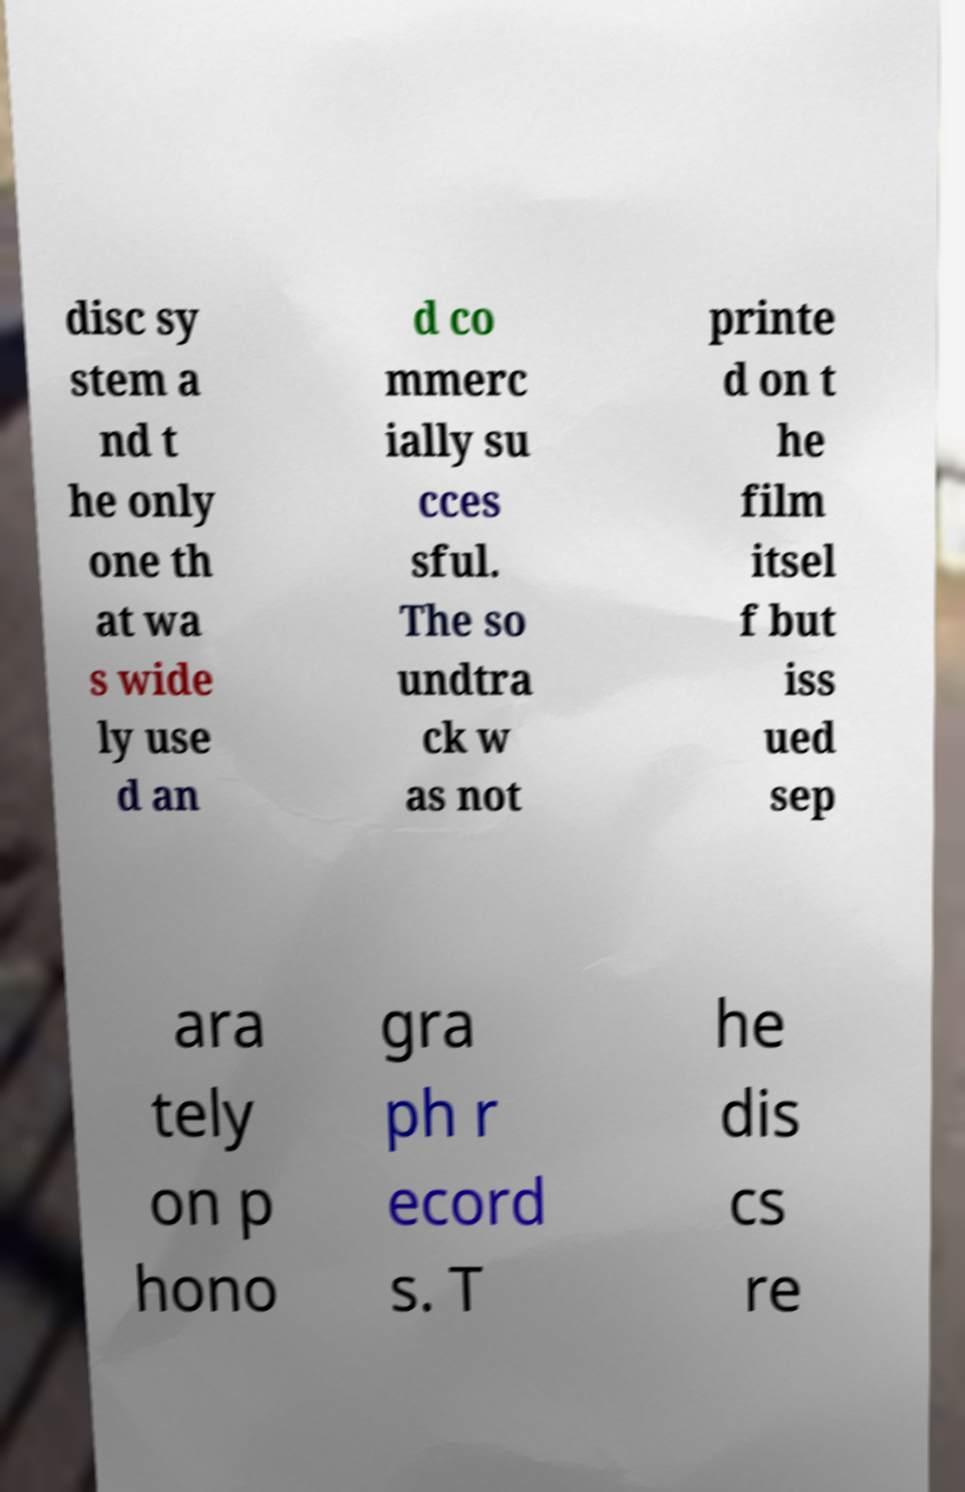Could you assist in decoding the text presented in this image and type it out clearly? disc sy stem a nd t he only one th at wa s wide ly use d an d co mmerc ially su cces sful. The so undtra ck w as not printe d on t he film itsel f but iss ued sep ara tely on p hono gra ph r ecord s. T he dis cs re 